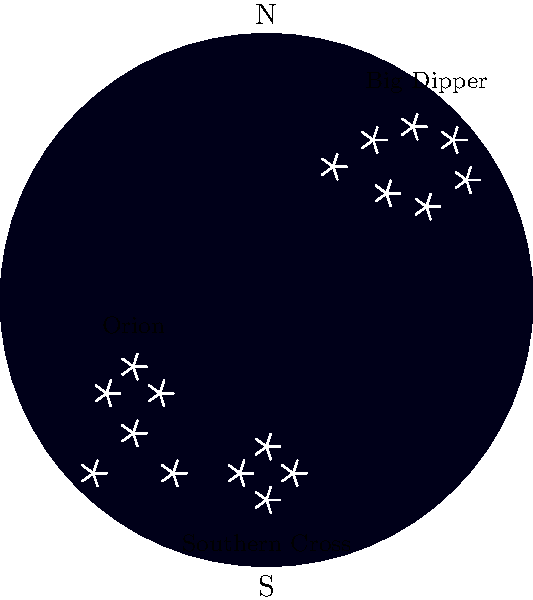As a Hawaiian restaurant owner, guests often ask about stargazing opportunities. Which of the constellations shown in this star map is typically not visible from Hawaii throughout the year, and why is its visibility limited? To answer this question, let's consider the visibility of each constellation from Hawaii:

1. Hawaii's location:
   - Hawaii is located at approximately 20°N latitude.

2. Big Dipper:
   - Part of Ursa Major, a circumpolar constellation for Hawaii.
   - Visible year-round from Hawaii.

3. Orion:
   - Visible from both Northern and Southern hemispheres.
   - Easily seen from Hawaii during winter months.

4. Southern Cross (Crux):
   - A southern hemisphere constellation.
   - Its declination ranges from about -55° to -65°.

5. Visibility calculation:
   - The lowest declination visible from a location is roughly:
     $$ \text{Lowest declination} = -(90° - \text{observer's latitude}) $$
   - For Hawaii: $-(90° - 20°) = -70°$

6. Southern Cross visibility:
   - Its declination (-55° to -65°) is mostly above Hawaii's lowest visible declination (-70°).
   - However, it appears very low on the horizon and is often obscured by the atmosphere or landscape.
   - Visible only for a short time during some parts of the year, if at all.

Therefore, the Southern Cross has limited visibility from Hawaii due to its southern declination, making it the constellation that is typically not visible throughout the year.
Answer: Southern Cross; too far south 